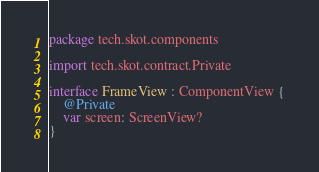Convert code to text. <code><loc_0><loc_0><loc_500><loc_500><_Kotlin_>package tech.skot.components

import tech.skot.contract.Private

interface FrameView : ComponentView {
    @Private
    var screen: ScreenView?
}</code> 